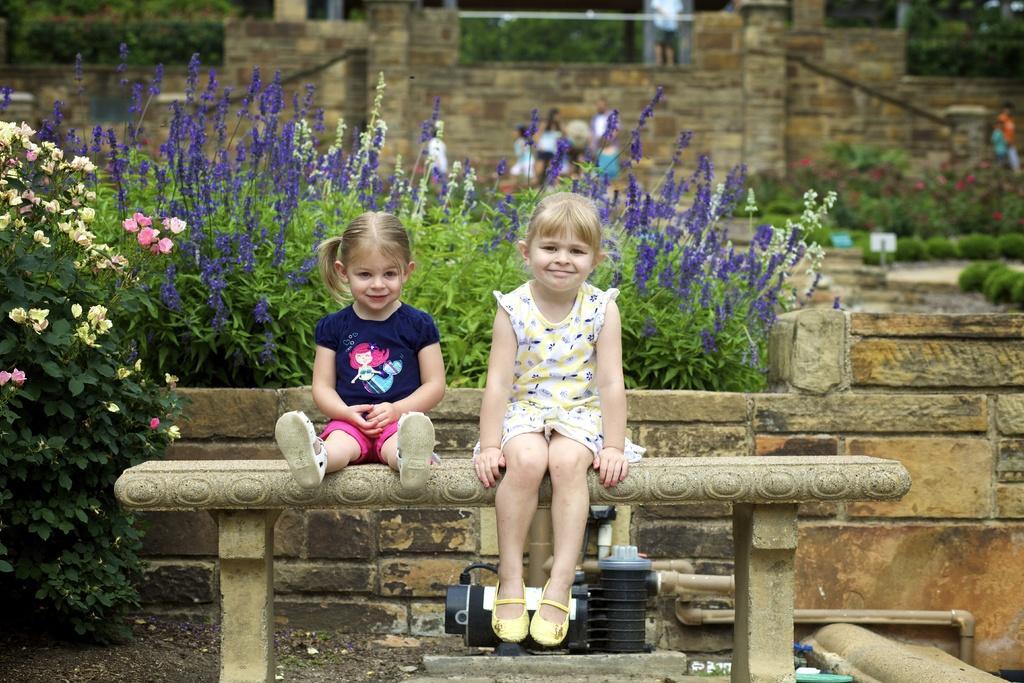Can you describe this image briefly? In this image I can see two persons are sitting on the bench. At the backside of them there are plants. In the background there is a wall. 